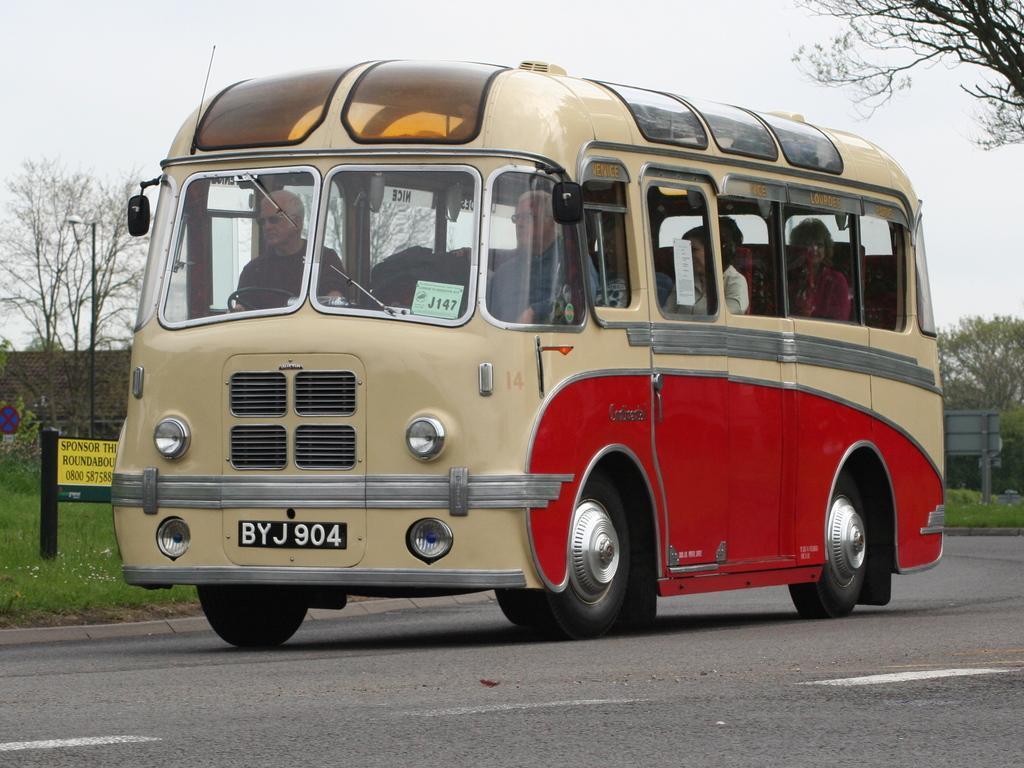Please provide a concise description of this image. In the image there is a bus moving on the road and beside the bus there is a garden with a lot of grass and in the front side of the garden there is some board kept beside the road and in the background there are few trees. 